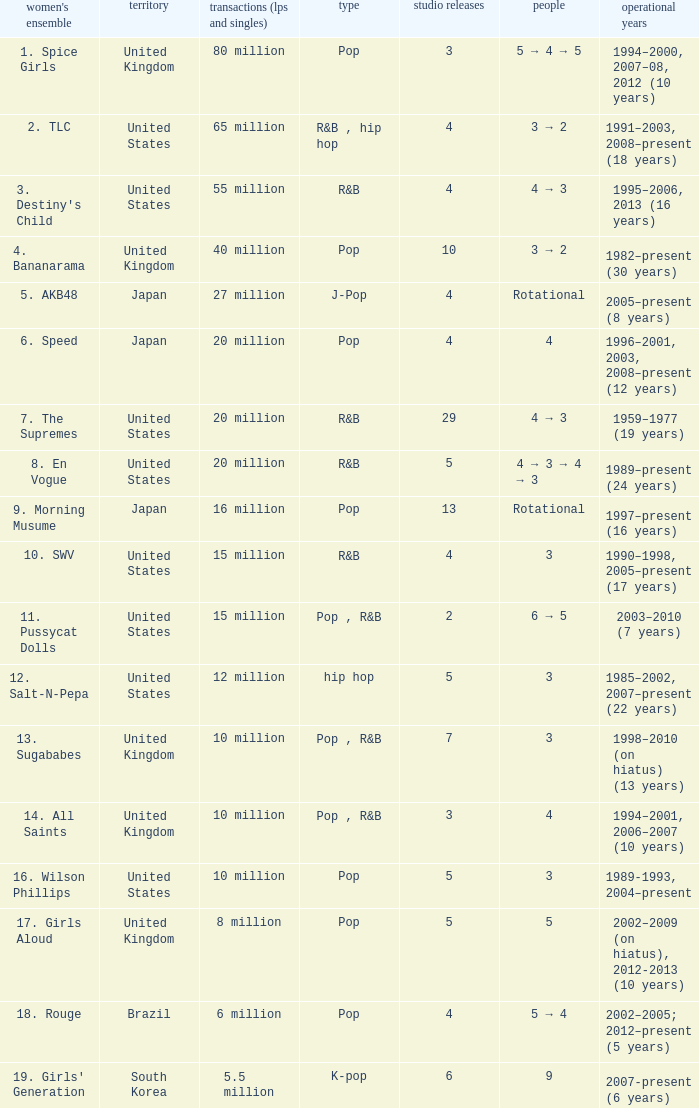What group had 29 studio albums? 7. The Supremes. 